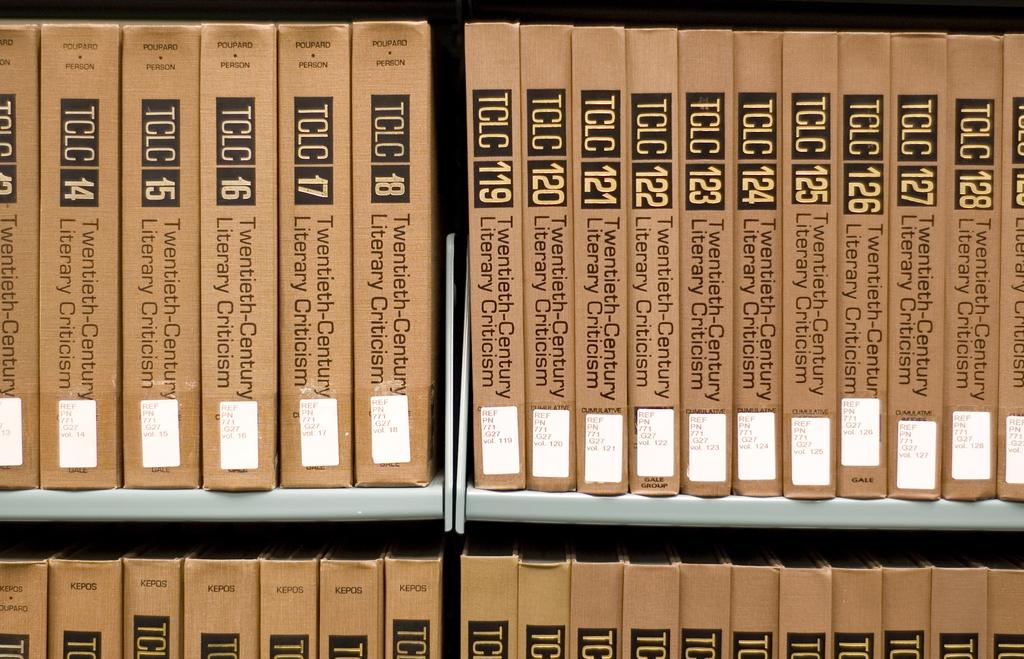<image>
Describe the image concisely. Many volumes of TCLC are lined up on library shelves. 